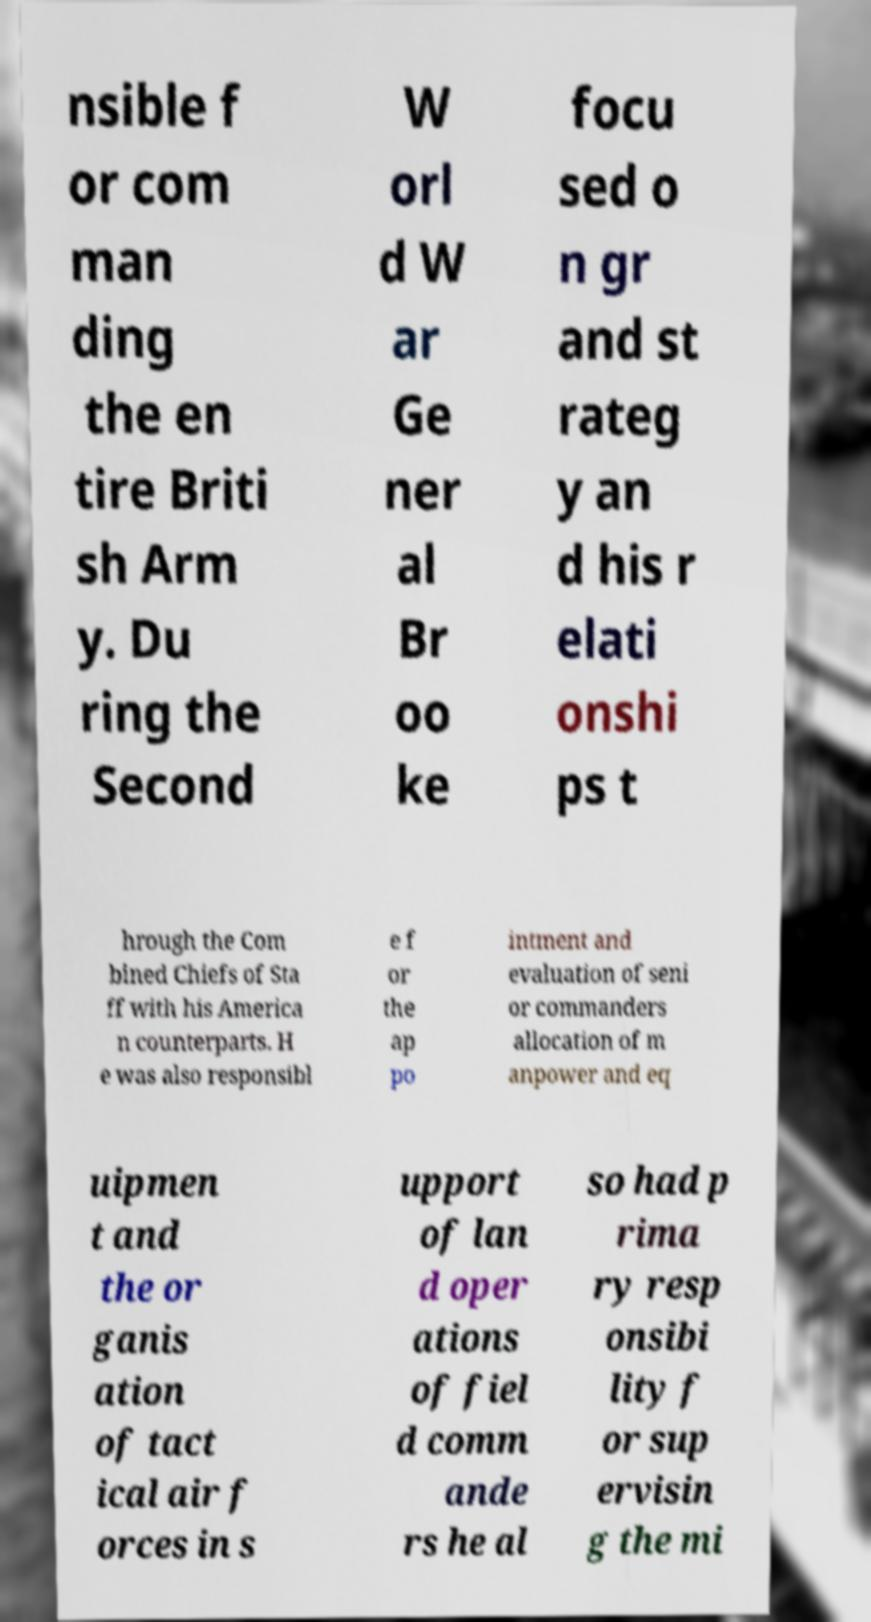Please identify and transcribe the text found in this image. nsible f or com man ding the en tire Briti sh Arm y. Du ring the Second W orl d W ar Ge ner al Br oo ke focu sed o n gr and st rateg y an d his r elati onshi ps t hrough the Com bined Chiefs of Sta ff with his America n counterparts. H e was also responsibl e f or the ap po intment and evaluation of seni or commanders allocation of m anpower and eq uipmen t and the or ganis ation of tact ical air f orces in s upport of lan d oper ations of fiel d comm ande rs he al so had p rima ry resp onsibi lity f or sup ervisin g the mi 